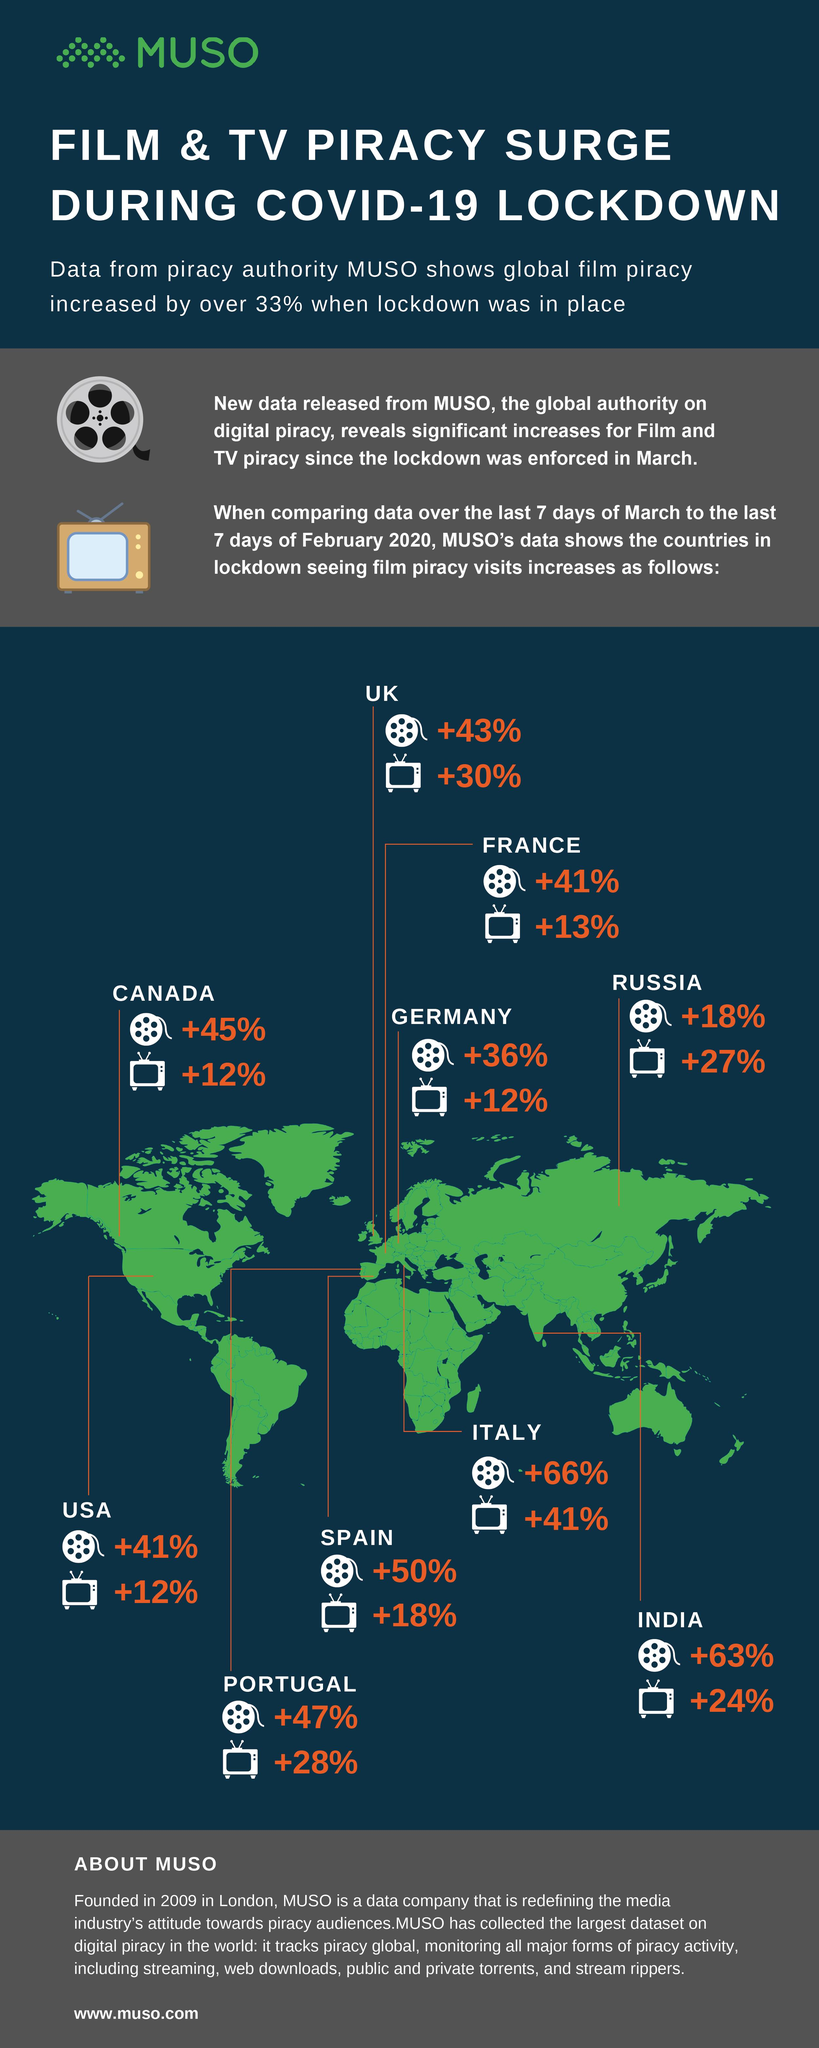Highlight a few significant elements in this photo. There are 11 television icons in the infographic. 